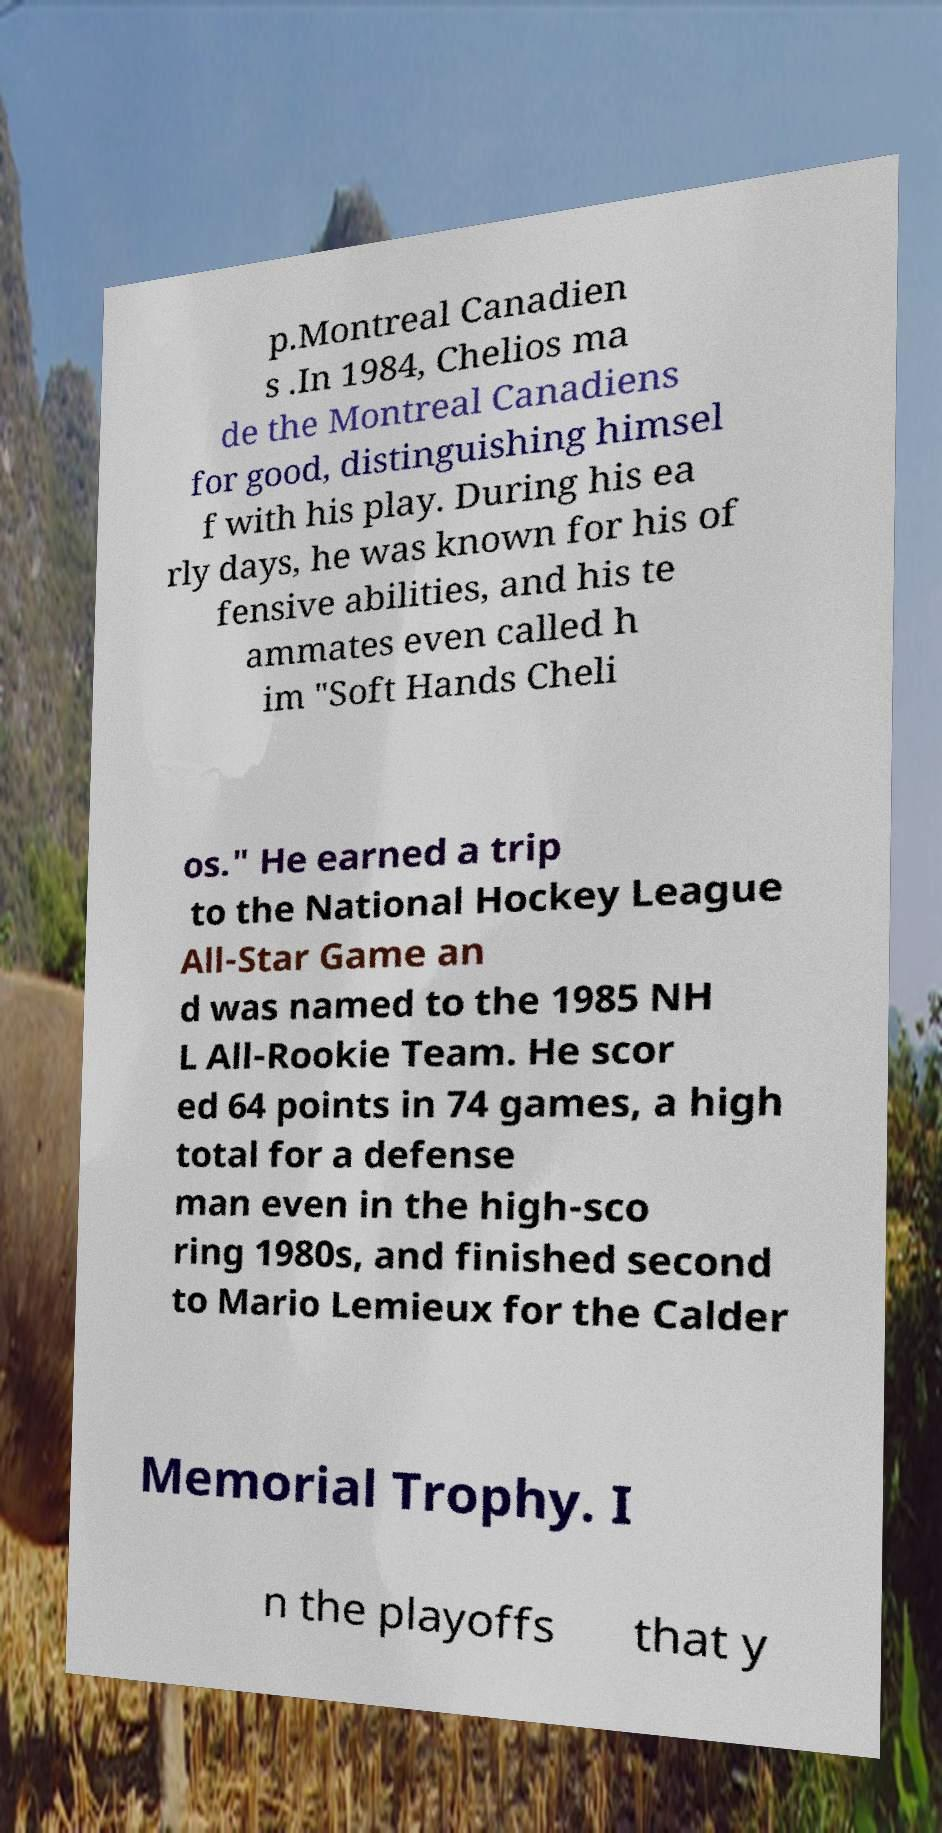Could you extract and type out the text from this image? p.Montreal Canadien s .In 1984, Chelios ma de the Montreal Canadiens for good, distinguishing himsel f with his play. During his ea rly days, he was known for his of fensive abilities, and his te ammates even called h im "Soft Hands Cheli os." He earned a trip to the National Hockey League All-Star Game an d was named to the 1985 NH L All-Rookie Team. He scor ed 64 points in 74 games, a high total for a defense man even in the high-sco ring 1980s, and finished second to Mario Lemieux for the Calder Memorial Trophy. I n the playoffs that y 